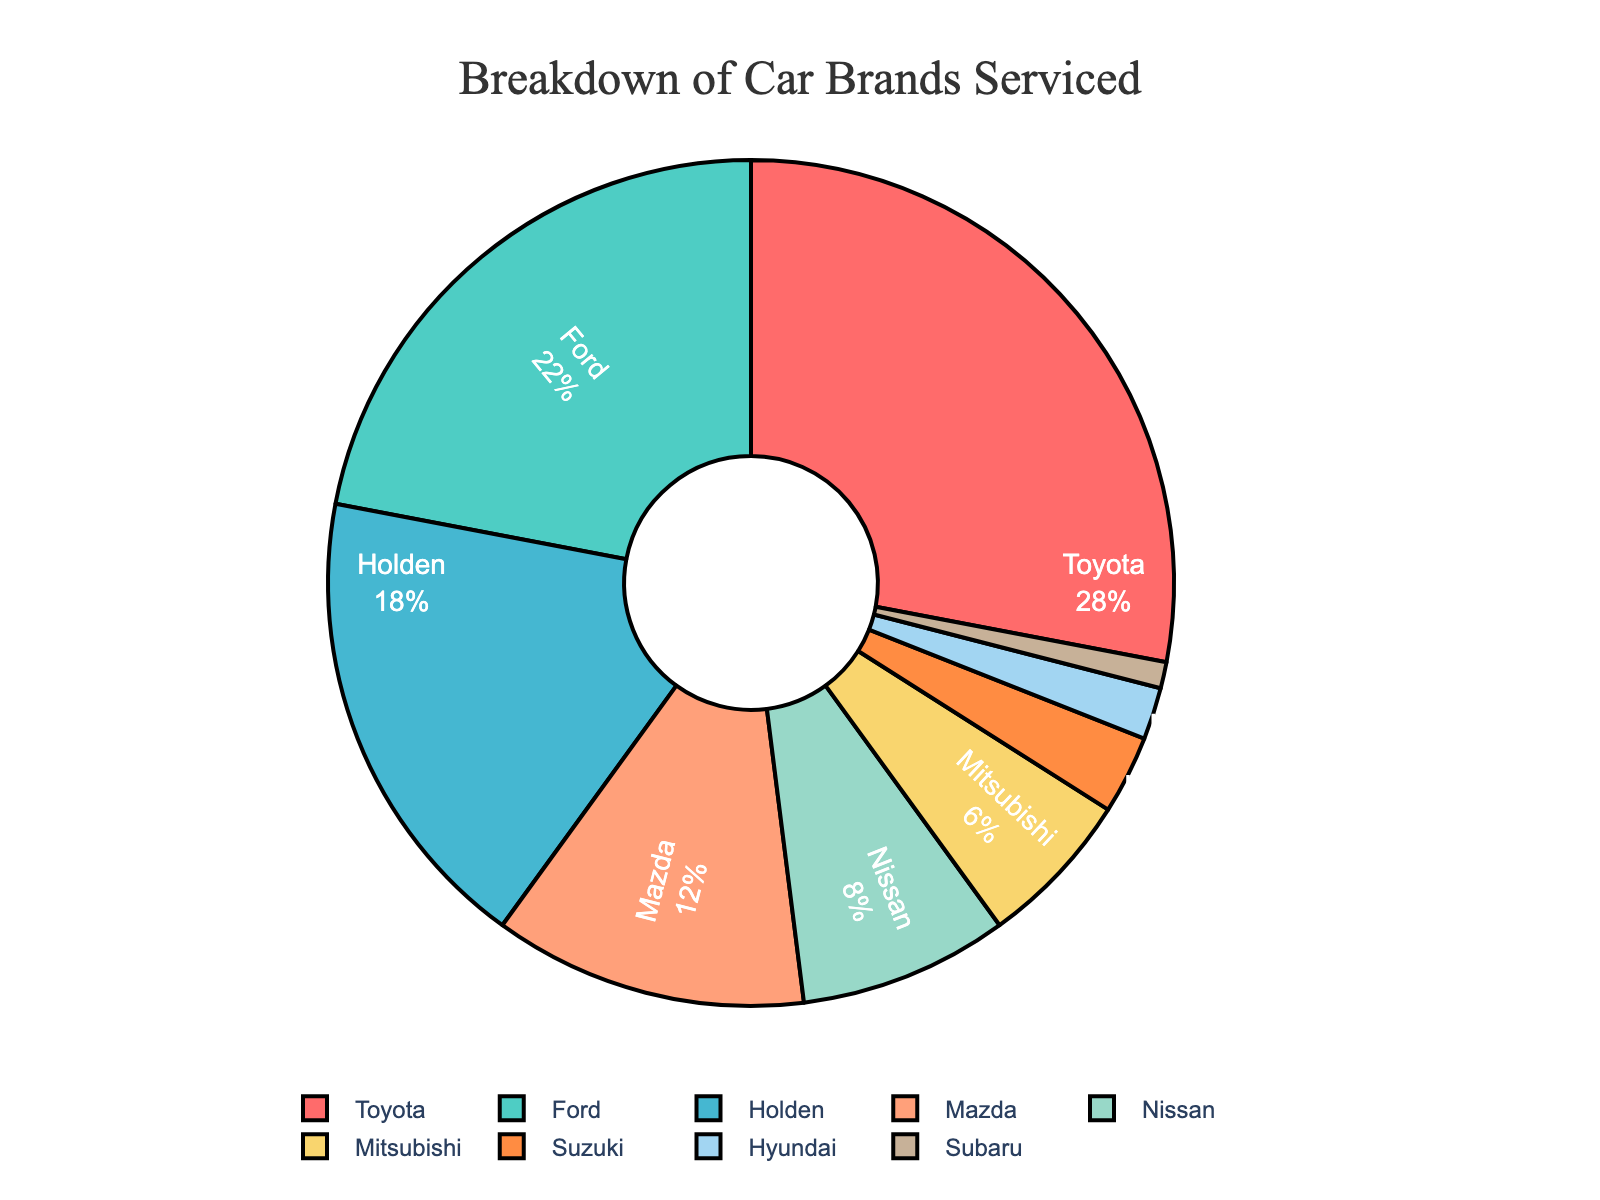What is the most serviced car brand? The pie chart shows that the largest segment is Toyota, which corresponds to 28% of the serviced cars, making it the most serviced brand.
Answer: Toyota Which car brand is serviced the least? According to the pie chart, the smallest segment is Subaru, representing only 1% of the serviced cars.
Answer: Subaru What percentage of serviced cars are either Nissan or Mitsubishi? Looking at the chart, Nissan is 8% and Mitsubishi is 6%. Adding these gives 8% + 6% = 14%.
Answer: 14% How much more popular is Toyota compared to Holden in terms of servicing? From the pie chart, Toyota accounts for 28% while Holden accounts for 18%. The difference is 28% - 18% = 10%.
Answer: 10% Compare the total percentage of cars serviced for Mazda and Hyundai. Is Mazda's percentage more than double Hyundai's? From the chart, Mazda accounts for 12% and Hyundai accounts for 2%. Double of Hyundai's percentage is 2% * 2 = 4%. Since 12% > 4%, Mazda’s percentage is indeed more than double Hyundai’s.
Answer: Yes What is the combined percentage of all Japanese car brands (Toyota, Mazda, Nissan, Mitsubishi, Suzuki, Subaru) serviced? The percentages for Japanese brands are: Toyota 28%, Mazda 12%, Nissan 8%, Mitsubishi 6%, Suzuki 3%, and Subaru 1%. Adding them together gives 28% + 12% + 8% + 6% + 3% + 1% = 58%.
Answer: 58% How many brands account for more than 10% of the servicing? From the pie chart, Toyota (28%), Ford (22%), and Holden (18%) each account for more than 10%. Therefore, there are 3 such brands.
Answer: 3 Is the percentage of Ford-serviced cars closer to the percentage of Holden-serviced cars or Mazda-serviced cars? Ford is 22%, Holden is 18%, and Mazda is 12%. The difference between Ford and Holden is 22% - 18% = 4%, and the difference between Ford and Mazda is 22% - 12% = 10%. Thus, Ford’s percentage is closer to Holden's than to Mazda's.
Answer: Holden 